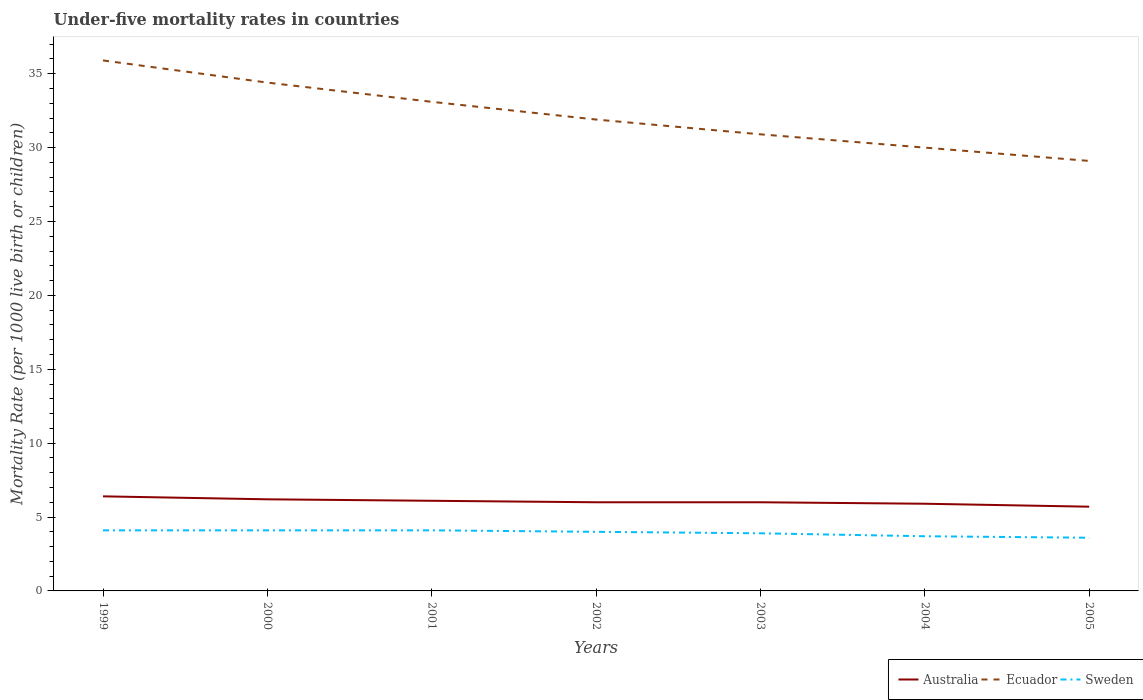How many different coloured lines are there?
Offer a very short reply. 3. Does the line corresponding to Ecuador intersect with the line corresponding to Australia?
Provide a short and direct response. No. Is the number of lines equal to the number of legend labels?
Your answer should be very brief. Yes. In which year was the under-five mortality rate in Sweden maximum?
Provide a short and direct response. 2005. What is the total under-five mortality rate in Sweden in the graph?
Provide a short and direct response. 0.1. What is the difference between the highest and the second highest under-five mortality rate in Sweden?
Offer a terse response. 0.5. Is the under-five mortality rate in Australia strictly greater than the under-five mortality rate in Sweden over the years?
Keep it short and to the point. No. What is the difference between two consecutive major ticks on the Y-axis?
Your answer should be very brief. 5. Are the values on the major ticks of Y-axis written in scientific E-notation?
Your answer should be compact. No. Does the graph contain grids?
Your answer should be compact. No. How many legend labels are there?
Make the answer very short. 3. What is the title of the graph?
Ensure brevity in your answer.  Under-five mortality rates in countries. Does "Morocco" appear as one of the legend labels in the graph?
Offer a very short reply. No. What is the label or title of the Y-axis?
Offer a very short reply. Mortality Rate (per 1000 live birth or children). What is the Mortality Rate (per 1000 live birth or children) in Ecuador in 1999?
Give a very brief answer. 35.9. What is the Mortality Rate (per 1000 live birth or children) of Ecuador in 2000?
Provide a succinct answer. 34.4. What is the Mortality Rate (per 1000 live birth or children) of Ecuador in 2001?
Your answer should be very brief. 33.1. What is the Mortality Rate (per 1000 live birth or children) in Sweden in 2001?
Your answer should be very brief. 4.1. What is the Mortality Rate (per 1000 live birth or children) in Ecuador in 2002?
Keep it short and to the point. 31.9. What is the Mortality Rate (per 1000 live birth or children) in Sweden in 2002?
Make the answer very short. 4. What is the Mortality Rate (per 1000 live birth or children) of Ecuador in 2003?
Your answer should be compact. 30.9. What is the Mortality Rate (per 1000 live birth or children) in Sweden in 2004?
Offer a very short reply. 3.7. What is the Mortality Rate (per 1000 live birth or children) of Ecuador in 2005?
Ensure brevity in your answer.  29.1. Across all years, what is the maximum Mortality Rate (per 1000 live birth or children) in Australia?
Give a very brief answer. 6.4. Across all years, what is the maximum Mortality Rate (per 1000 live birth or children) in Ecuador?
Give a very brief answer. 35.9. Across all years, what is the minimum Mortality Rate (per 1000 live birth or children) in Ecuador?
Ensure brevity in your answer.  29.1. What is the total Mortality Rate (per 1000 live birth or children) in Australia in the graph?
Provide a short and direct response. 42.3. What is the total Mortality Rate (per 1000 live birth or children) in Ecuador in the graph?
Give a very brief answer. 225.3. What is the difference between the Mortality Rate (per 1000 live birth or children) of Ecuador in 1999 and that in 2000?
Provide a succinct answer. 1.5. What is the difference between the Mortality Rate (per 1000 live birth or children) of Sweden in 1999 and that in 2000?
Make the answer very short. 0. What is the difference between the Mortality Rate (per 1000 live birth or children) in Australia in 1999 and that in 2001?
Ensure brevity in your answer.  0.3. What is the difference between the Mortality Rate (per 1000 live birth or children) of Ecuador in 1999 and that in 2001?
Offer a terse response. 2.8. What is the difference between the Mortality Rate (per 1000 live birth or children) of Australia in 1999 and that in 2002?
Your response must be concise. 0.4. What is the difference between the Mortality Rate (per 1000 live birth or children) in Sweden in 1999 and that in 2002?
Provide a short and direct response. 0.1. What is the difference between the Mortality Rate (per 1000 live birth or children) of Australia in 1999 and that in 2003?
Keep it short and to the point. 0.4. What is the difference between the Mortality Rate (per 1000 live birth or children) of Australia in 1999 and that in 2004?
Your response must be concise. 0.5. What is the difference between the Mortality Rate (per 1000 live birth or children) in Ecuador in 1999 and that in 2004?
Your answer should be very brief. 5.9. What is the difference between the Mortality Rate (per 1000 live birth or children) in Sweden in 1999 and that in 2004?
Your answer should be very brief. 0.4. What is the difference between the Mortality Rate (per 1000 live birth or children) in Ecuador in 1999 and that in 2005?
Make the answer very short. 6.8. What is the difference between the Mortality Rate (per 1000 live birth or children) of Sweden in 1999 and that in 2005?
Keep it short and to the point. 0.5. What is the difference between the Mortality Rate (per 1000 live birth or children) in Sweden in 2000 and that in 2001?
Your response must be concise. 0. What is the difference between the Mortality Rate (per 1000 live birth or children) in Australia in 2000 and that in 2003?
Offer a very short reply. 0.2. What is the difference between the Mortality Rate (per 1000 live birth or children) of Ecuador in 2000 and that in 2003?
Your response must be concise. 3.5. What is the difference between the Mortality Rate (per 1000 live birth or children) of Sweden in 2000 and that in 2003?
Provide a short and direct response. 0.2. What is the difference between the Mortality Rate (per 1000 live birth or children) of Australia in 2000 and that in 2005?
Provide a short and direct response. 0.5. What is the difference between the Mortality Rate (per 1000 live birth or children) in Ecuador in 2000 and that in 2005?
Your response must be concise. 5.3. What is the difference between the Mortality Rate (per 1000 live birth or children) of Ecuador in 2001 and that in 2002?
Provide a short and direct response. 1.2. What is the difference between the Mortality Rate (per 1000 live birth or children) in Australia in 2001 and that in 2003?
Provide a short and direct response. 0.1. What is the difference between the Mortality Rate (per 1000 live birth or children) in Ecuador in 2001 and that in 2003?
Ensure brevity in your answer.  2.2. What is the difference between the Mortality Rate (per 1000 live birth or children) of Sweden in 2001 and that in 2003?
Your answer should be compact. 0.2. What is the difference between the Mortality Rate (per 1000 live birth or children) of Australia in 2001 and that in 2004?
Your answer should be very brief. 0.2. What is the difference between the Mortality Rate (per 1000 live birth or children) of Ecuador in 2001 and that in 2004?
Ensure brevity in your answer.  3.1. What is the difference between the Mortality Rate (per 1000 live birth or children) in Australia in 2001 and that in 2005?
Your response must be concise. 0.4. What is the difference between the Mortality Rate (per 1000 live birth or children) of Sweden in 2001 and that in 2005?
Your answer should be compact. 0.5. What is the difference between the Mortality Rate (per 1000 live birth or children) in Australia in 2002 and that in 2003?
Your response must be concise. 0. What is the difference between the Mortality Rate (per 1000 live birth or children) of Sweden in 2002 and that in 2003?
Provide a short and direct response. 0.1. What is the difference between the Mortality Rate (per 1000 live birth or children) of Australia in 2002 and that in 2004?
Make the answer very short. 0.1. What is the difference between the Mortality Rate (per 1000 live birth or children) of Ecuador in 2002 and that in 2004?
Offer a very short reply. 1.9. What is the difference between the Mortality Rate (per 1000 live birth or children) in Sweden in 2002 and that in 2004?
Provide a succinct answer. 0.3. What is the difference between the Mortality Rate (per 1000 live birth or children) of Australia in 2002 and that in 2005?
Your answer should be compact. 0.3. What is the difference between the Mortality Rate (per 1000 live birth or children) of Sweden in 2002 and that in 2005?
Provide a succinct answer. 0.4. What is the difference between the Mortality Rate (per 1000 live birth or children) of Australia in 2003 and that in 2004?
Make the answer very short. 0.1. What is the difference between the Mortality Rate (per 1000 live birth or children) in Australia in 2003 and that in 2005?
Provide a succinct answer. 0.3. What is the difference between the Mortality Rate (per 1000 live birth or children) in Ecuador in 2003 and that in 2005?
Make the answer very short. 1.8. What is the difference between the Mortality Rate (per 1000 live birth or children) in Sweden in 2003 and that in 2005?
Provide a short and direct response. 0.3. What is the difference between the Mortality Rate (per 1000 live birth or children) of Australia in 2004 and that in 2005?
Your answer should be compact. 0.2. What is the difference between the Mortality Rate (per 1000 live birth or children) in Australia in 1999 and the Mortality Rate (per 1000 live birth or children) in Ecuador in 2000?
Your answer should be very brief. -28. What is the difference between the Mortality Rate (per 1000 live birth or children) in Australia in 1999 and the Mortality Rate (per 1000 live birth or children) in Sweden in 2000?
Offer a very short reply. 2.3. What is the difference between the Mortality Rate (per 1000 live birth or children) in Ecuador in 1999 and the Mortality Rate (per 1000 live birth or children) in Sweden in 2000?
Give a very brief answer. 31.8. What is the difference between the Mortality Rate (per 1000 live birth or children) in Australia in 1999 and the Mortality Rate (per 1000 live birth or children) in Ecuador in 2001?
Provide a short and direct response. -26.7. What is the difference between the Mortality Rate (per 1000 live birth or children) of Australia in 1999 and the Mortality Rate (per 1000 live birth or children) of Sweden in 2001?
Give a very brief answer. 2.3. What is the difference between the Mortality Rate (per 1000 live birth or children) of Ecuador in 1999 and the Mortality Rate (per 1000 live birth or children) of Sweden in 2001?
Keep it short and to the point. 31.8. What is the difference between the Mortality Rate (per 1000 live birth or children) of Australia in 1999 and the Mortality Rate (per 1000 live birth or children) of Ecuador in 2002?
Your answer should be compact. -25.5. What is the difference between the Mortality Rate (per 1000 live birth or children) in Ecuador in 1999 and the Mortality Rate (per 1000 live birth or children) in Sweden in 2002?
Ensure brevity in your answer.  31.9. What is the difference between the Mortality Rate (per 1000 live birth or children) in Australia in 1999 and the Mortality Rate (per 1000 live birth or children) in Ecuador in 2003?
Your answer should be very brief. -24.5. What is the difference between the Mortality Rate (per 1000 live birth or children) of Australia in 1999 and the Mortality Rate (per 1000 live birth or children) of Ecuador in 2004?
Keep it short and to the point. -23.6. What is the difference between the Mortality Rate (per 1000 live birth or children) in Ecuador in 1999 and the Mortality Rate (per 1000 live birth or children) in Sweden in 2004?
Offer a very short reply. 32.2. What is the difference between the Mortality Rate (per 1000 live birth or children) of Australia in 1999 and the Mortality Rate (per 1000 live birth or children) of Ecuador in 2005?
Make the answer very short. -22.7. What is the difference between the Mortality Rate (per 1000 live birth or children) of Ecuador in 1999 and the Mortality Rate (per 1000 live birth or children) of Sweden in 2005?
Offer a terse response. 32.3. What is the difference between the Mortality Rate (per 1000 live birth or children) in Australia in 2000 and the Mortality Rate (per 1000 live birth or children) in Ecuador in 2001?
Your response must be concise. -26.9. What is the difference between the Mortality Rate (per 1000 live birth or children) in Ecuador in 2000 and the Mortality Rate (per 1000 live birth or children) in Sweden in 2001?
Provide a short and direct response. 30.3. What is the difference between the Mortality Rate (per 1000 live birth or children) of Australia in 2000 and the Mortality Rate (per 1000 live birth or children) of Ecuador in 2002?
Provide a succinct answer. -25.7. What is the difference between the Mortality Rate (per 1000 live birth or children) in Ecuador in 2000 and the Mortality Rate (per 1000 live birth or children) in Sweden in 2002?
Provide a short and direct response. 30.4. What is the difference between the Mortality Rate (per 1000 live birth or children) of Australia in 2000 and the Mortality Rate (per 1000 live birth or children) of Ecuador in 2003?
Your response must be concise. -24.7. What is the difference between the Mortality Rate (per 1000 live birth or children) in Australia in 2000 and the Mortality Rate (per 1000 live birth or children) in Sweden in 2003?
Provide a short and direct response. 2.3. What is the difference between the Mortality Rate (per 1000 live birth or children) of Ecuador in 2000 and the Mortality Rate (per 1000 live birth or children) of Sweden in 2003?
Offer a very short reply. 30.5. What is the difference between the Mortality Rate (per 1000 live birth or children) of Australia in 2000 and the Mortality Rate (per 1000 live birth or children) of Ecuador in 2004?
Make the answer very short. -23.8. What is the difference between the Mortality Rate (per 1000 live birth or children) of Ecuador in 2000 and the Mortality Rate (per 1000 live birth or children) of Sweden in 2004?
Offer a terse response. 30.7. What is the difference between the Mortality Rate (per 1000 live birth or children) in Australia in 2000 and the Mortality Rate (per 1000 live birth or children) in Ecuador in 2005?
Your answer should be compact. -22.9. What is the difference between the Mortality Rate (per 1000 live birth or children) of Australia in 2000 and the Mortality Rate (per 1000 live birth or children) of Sweden in 2005?
Keep it short and to the point. 2.6. What is the difference between the Mortality Rate (per 1000 live birth or children) in Ecuador in 2000 and the Mortality Rate (per 1000 live birth or children) in Sweden in 2005?
Provide a short and direct response. 30.8. What is the difference between the Mortality Rate (per 1000 live birth or children) of Australia in 2001 and the Mortality Rate (per 1000 live birth or children) of Ecuador in 2002?
Your answer should be compact. -25.8. What is the difference between the Mortality Rate (per 1000 live birth or children) in Australia in 2001 and the Mortality Rate (per 1000 live birth or children) in Sweden in 2002?
Your response must be concise. 2.1. What is the difference between the Mortality Rate (per 1000 live birth or children) in Ecuador in 2001 and the Mortality Rate (per 1000 live birth or children) in Sweden in 2002?
Keep it short and to the point. 29.1. What is the difference between the Mortality Rate (per 1000 live birth or children) of Australia in 2001 and the Mortality Rate (per 1000 live birth or children) of Ecuador in 2003?
Your answer should be very brief. -24.8. What is the difference between the Mortality Rate (per 1000 live birth or children) in Ecuador in 2001 and the Mortality Rate (per 1000 live birth or children) in Sweden in 2003?
Make the answer very short. 29.2. What is the difference between the Mortality Rate (per 1000 live birth or children) of Australia in 2001 and the Mortality Rate (per 1000 live birth or children) of Ecuador in 2004?
Your response must be concise. -23.9. What is the difference between the Mortality Rate (per 1000 live birth or children) in Australia in 2001 and the Mortality Rate (per 1000 live birth or children) in Sweden in 2004?
Provide a short and direct response. 2.4. What is the difference between the Mortality Rate (per 1000 live birth or children) in Ecuador in 2001 and the Mortality Rate (per 1000 live birth or children) in Sweden in 2004?
Give a very brief answer. 29.4. What is the difference between the Mortality Rate (per 1000 live birth or children) of Australia in 2001 and the Mortality Rate (per 1000 live birth or children) of Ecuador in 2005?
Offer a terse response. -23. What is the difference between the Mortality Rate (per 1000 live birth or children) in Australia in 2001 and the Mortality Rate (per 1000 live birth or children) in Sweden in 2005?
Offer a very short reply. 2.5. What is the difference between the Mortality Rate (per 1000 live birth or children) in Ecuador in 2001 and the Mortality Rate (per 1000 live birth or children) in Sweden in 2005?
Your answer should be very brief. 29.5. What is the difference between the Mortality Rate (per 1000 live birth or children) in Australia in 2002 and the Mortality Rate (per 1000 live birth or children) in Ecuador in 2003?
Provide a succinct answer. -24.9. What is the difference between the Mortality Rate (per 1000 live birth or children) in Ecuador in 2002 and the Mortality Rate (per 1000 live birth or children) in Sweden in 2003?
Your response must be concise. 28. What is the difference between the Mortality Rate (per 1000 live birth or children) in Australia in 2002 and the Mortality Rate (per 1000 live birth or children) in Ecuador in 2004?
Provide a succinct answer. -24. What is the difference between the Mortality Rate (per 1000 live birth or children) of Ecuador in 2002 and the Mortality Rate (per 1000 live birth or children) of Sweden in 2004?
Your response must be concise. 28.2. What is the difference between the Mortality Rate (per 1000 live birth or children) in Australia in 2002 and the Mortality Rate (per 1000 live birth or children) in Ecuador in 2005?
Make the answer very short. -23.1. What is the difference between the Mortality Rate (per 1000 live birth or children) of Australia in 2002 and the Mortality Rate (per 1000 live birth or children) of Sweden in 2005?
Provide a short and direct response. 2.4. What is the difference between the Mortality Rate (per 1000 live birth or children) in Ecuador in 2002 and the Mortality Rate (per 1000 live birth or children) in Sweden in 2005?
Provide a short and direct response. 28.3. What is the difference between the Mortality Rate (per 1000 live birth or children) of Australia in 2003 and the Mortality Rate (per 1000 live birth or children) of Ecuador in 2004?
Provide a succinct answer. -24. What is the difference between the Mortality Rate (per 1000 live birth or children) of Ecuador in 2003 and the Mortality Rate (per 1000 live birth or children) of Sweden in 2004?
Give a very brief answer. 27.2. What is the difference between the Mortality Rate (per 1000 live birth or children) in Australia in 2003 and the Mortality Rate (per 1000 live birth or children) in Ecuador in 2005?
Make the answer very short. -23.1. What is the difference between the Mortality Rate (per 1000 live birth or children) in Australia in 2003 and the Mortality Rate (per 1000 live birth or children) in Sweden in 2005?
Ensure brevity in your answer.  2.4. What is the difference between the Mortality Rate (per 1000 live birth or children) of Ecuador in 2003 and the Mortality Rate (per 1000 live birth or children) of Sweden in 2005?
Offer a very short reply. 27.3. What is the difference between the Mortality Rate (per 1000 live birth or children) in Australia in 2004 and the Mortality Rate (per 1000 live birth or children) in Ecuador in 2005?
Give a very brief answer. -23.2. What is the difference between the Mortality Rate (per 1000 live birth or children) of Australia in 2004 and the Mortality Rate (per 1000 live birth or children) of Sweden in 2005?
Keep it short and to the point. 2.3. What is the difference between the Mortality Rate (per 1000 live birth or children) of Ecuador in 2004 and the Mortality Rate (per 1000 live birth or children) of Sweden in 2005?
Make the answer very short. 26.4. What is the average Mortality Rate (per 1000 live birth or children) of Australia per year?
Your response must be concise. 6.04. What is the average Mortality Rate (per 1000 live birth or children) of Ecuador per year?
Your response must be concise. 32.19. What is the average Mortality Rate (per 1000 live birth or children) in Sweden per year?
Offer a very short reply. 3.93. In the year 1999, what is the difference between the Mortality Rate (per 1000 live birth or children) in Australia and Mortality Rate (per 1000 live birth or children) in Ecuador?
Provide a short and direct response. -29.5. In the year 1999, what is the difference between the Mortality Rate (per 1000 live birth or children) of Australia and Mortality Rate (per 1000 live birth or children) of Sweden?
Offer a terse response. 2.3. In the year 1999, what is the difference between the Mortality Rate (per 1000 live birth or children) of Ecuador and Mortality Rate (per 1000 live birth or children) of Sweden?
Provide a succinct answer. 31.8. In the year 2000, what is the difference between the Mortality Rate (per 1000 live birth or children) in Australia and Mortality Rate (per 1000 live birth or children) in Ecuador?
Give a very brief answer. -28.2. In the year 2000, what is the difference between the Mortality Rate (per 1000 live birth or children) in Ecuador and Mortality Rate (per 1000 live birth or children) in Sweden?
Give a very brief answer. 30.3. In the year 2001, what is the difference between the Mortality Rate (per 1000 live birth or children) in Ecuador and Mortality Rate (per 1000 live birth or children) in Sweden?
Offer a very short reply. 29. In the year 2002, what is the difference between the Mortality Rate (per 1000 live birth or children) of Australia and Mortality Rate (per 1000 live birth or children) of Ecuador?
Ensure brevity in your answer.  -25.9. In the year 2002, what is the difference between the Mortality Rate (per 1000 live birth or children) of Ecuador and Mortality Rate (per 1000 live birth or children) of Sweden?
Provide a succinct answer. 27.9. In the year 2003, what is the difference between the Mortality Rate (per 1000 live birth or children) in Australia and Mortality Rate (per 1000 live birth or children) in Ecuador?
Provide a succinct answer. -24.9. In the year 2003, what is the difference between the Mortality Rate (per 1000 live birth or children) of Ecuador and Mortality Rate (per 1000 live birth or children) of Sweden?
Keep it short and to the point. 27. In the year 2004, what is the difference between the Mortality Rate (per 1000 live birth or children) of Australia and Mortality Rate (per 1000 live birth or children) of Ecuador?
Make the answer very short. -24.1. In the year 2004, what is the difference between the Mortality Rate (per 1000 live birth or children) in Ecuador and Mortality Rate (per 1000 live birth or children) in Sweden?
Ensure brevity in your answer.  26.3. In the year 2005, what is the difference between the Mortality Rate (per 1000 live birth or children) in Australia and Mortality Rate (per 1000 live birth or children) in Ecuador?
Ensure brevity in your answer.  -23.4. In the year 2005, what is the difference between the Mortality Rate (per 1000 live birth or children) in Australia and Mortality Rate (per 1000 live birth or children) in Sweden?
Offer a terse response. 2.1. In the year 2005, what is the difference between the Mortality Rate (per 1000 live birth or children) of Ecuador and Mortality Rate (per 1000 live birth or children) of Sweden?
Your answer should be very brief. 25.5. What is the ratio of the Mortality Rate (per 1000 live birth or children) of Australia in 1999 to that in 2000?
Provide a short and direct response. 1.03. What is the ratio of the Mortality Rate (per 1000 live birth or children) of Ecuador in 1999 to that in 2000?
Make the answer very short. 1.04. What is the ratio of the Mortality Rate (per 1000 live birth or children) in Australia in 1999 to that in 2001?
Make the answer very short. 1.05. What is the ratio of the Mortality Rate (per 1000 live birth or children) in Ecuador in 1999 to that in 2001?
Provide a succinct answer. 1.08. What is the ratio of the Mortality Rate (per 1000 live birth or children) of Sweden in 1999 to that in 2001?
Provide a short and direct response. 1. What is the ratio of the Mortality Rate (per 1000 live birth or children) in Australia in 1999 to that in 2002?
Ensure brevity in your answer.  1.07. What is the ratio of the Mortality Rate (per 1000 live birth or children) in Ecuador in 1999 to that in 2002?
Your answer should be compact. 1.13. What is the ratio of the Mortality Rate (per 1000 live birth or children) in Sweden in 1999 to that in 2002?
Give a very brief answer. 1.02. What is the ratio of the Mortality Rate (per 1000 live birth or children) of Australia in 1999 to that in 2003?
Provide a succinct answer. 1.07. What is the ratio of the Mortality Rate (per 1000 live birth or children) of Ecuador in 1999 to that in 2003?
Provide a succinct answer. 1.16. What is the ratio of the Mortality Rate (per 1000 live birth or children) in Sweden in 1999 to that in 2003?
Your answer should be compact. 1.05. What is the ratio of the Mortality Rate (per 1000 live birth or children) in Australia in 1999 to that in 2004?
Your answer should be compact. 1.08. What is the ratio of the Mortality Rate (per 1000 live birth or children) of Ecuador in 1999 to that in 2004?
Offer a terse response. 1.2. What is the ratio of the Mortality Rate (per 1000 live birth or children) of Sweden in 1999 to that in 2004?
Provide a short and direct response. 1.11. What is the ratio of the Mortality Rate (per 1000 live birth or children) of Australia in 1999 to that in 2005?
Make the answer very short. 1.12. What is the ratio of the Mortality Rate (per 1000 live birth or children) of Ecuador in 1999 to that in 2005?
Offer a terse response. 1.23. What is the ratio of the Mortality Rate (per 1000 live birth or children) of Sweden in 1999 to that in 2005?
Make the answer very short. 1.14. What is the ratio of the Mortality Rate (per 1000 live birth or children) in Australia in 2000 to that in 2001?
Give a very brief answer. 1.02. What is the ratio of the Mortality Rate (per 1000 live birth or children) in Ecuador in 2000 to that in 2001?
Provide a short and direct response. 1.04. What is the ratio of the Mortality Rate (per 1000 live birth or children) in Ecuador in 2000 to that in 2002?
Provide a short and direct response. 1.08. What is the ratio of the Mortality Rate (per 1000 live birth or children) in Sweden in 2000 to that in 2002?
Provide a short and direct response. 1.02. What is the ratio of the Mortality Rate (per 1000 live birth or children) of Australia in 2000 to that in 2003?
Ensure brevity in your answer.  1.03. What is the ratio of the Mortality Rate (per 1000 live birth or children) in Ecuador in 2000 to that in 2003?
Ensure brevity in your answer.  1.11. What is the ratio of the Mortality Rate (per 1000 live birth or children) in Sweden in 2000 to that in 2003?
Make the answer very short. 1.05. What is the ratio of the Mortality Rate (per 1000 live birth or children) of Australia in 2000 to that in 2004?
Ensure brevity in your answer.  1.05. What is the ratio of the Mortality Rate (per 1000 live birth or children) in Ecuador in 2000 to that in 2004?
Your answer should be compact. 1.15. What is the ratio of the Mortality Rate (per 1000 live birth or children) of Sweden in 2000 to that in 2004?
Give a very brief answer. 1.11. What is the ratio of the Mortality Rate (per 1000 live birth or children) of Australia in 2000 to that in 2005?
Ensure brevity in your answer.  1.09. What is the ratio of the Mortality Rate (per 1000 live birth or children) of Ecuador in 2000 to that in 2005?
Provide a short and direct response. 1.18. What is the ratio of the Mortality Rate (per 1000 live birth or children) of Sweden in 2000 to that in 2005?
Provide a short and direct response. 1.14. What is the ratio of the Mortality Rate (per 1000 live birth or children) in Australia in 2001 to that in 2002?
Make the answer very short. 1.02. What is the ratio of the Mortality Rate (per 1000 live birth or children) of Ecuador in 2001 to that in 2002?
Provide a succinct answer. 1.04. What is the ratio of the Mortality Rate (per 1000 live birth or children) of Sweden in 2001 to that in 2002?
Give a very brief answer. 1.02. What is the ratio of the Mortality Rate (per 1000 live birth or children) of Australia in 2001 to that in 2003?
Make the answer very short. 1.02. What is the ratio of the Mortality Rate (per 1000 live birth or children) in Ecuador in 2001 to that in 2003?
Your answer should be compact. 1.07. What is the ratio of the Mortality Rate (per 1000 live birth or children) in Sweden in 2001 to that in 2003?
Your answer should be compact. 1.05. What is the ratio of the Mortality Rate (per 1000 live birth or children) in Australia in 2001 to that in 2004?
Your response must be concise. 1.03. What is the ratio of the Mortality Rate (per 1000 live birth or children) of Ecuador in 2001 to that in 2004?
Your answer should be compact. 1.1. What is the ratio of the Mortality Rate (per 1000 live birth or children) in Sweden in 2001 to that in 2004?
Your answer should be compact. 1.11. What is the ratio of the Mortality Rate (per 1000 live birth or children) of Australia in 2001 to that in 2005?
Give a very brief answer. 1.07. What is the ratio of the Mortality Rate (per 1000 live birth or children) in Ecuador in 2001 to that in 2005?
Your answer should be compact. 1.14. What is the ratio of the Mortality Rate (per 1000 live birth or children) in Sweden in 2001 to that in 2005?
Keep it short and to the point. 1.14. What is the ratio of the Mortality Rate (per 1000 live birth or children) in Ecuador in 2002 to that in 2003?
Your response must be concise. 1.03. What is the ratio of the Mortality Rate (per 1000 live birth or children) of Sweden in 2002 to that in 2003?
Give a very brief answer. 1.03. What is the ratio of the Mortality Rate (per 1000 live birth or children) of Australia in 2002 to that in 2004?
Provide a short and direct response. 1.02. What is the ratio of the Mortality Rate (per 1000 live birth or children) of Ecuador in 2002 to that in 2004?
Your answer should be very brief. 1.06. What is the ratio of the Mortality Rate (per 1000 live birth or children) of Sweden in 2002 to that in 2004?
Make the answer very short. 1.08. What is the ratio of the Mortality Rate (per 1000 live birth or children) of Australia in 2002 to that in 2005?
Offer a very short reply. 1.05. What is the ratio of the Mortality Rate (per 1000 live birth or children) in Ecuador in 2002 to that in 2005?
Offer a very short reply. 1.1. What is the ratio of the Mortality Rate (per 1000 live birth or children) of Australia in 2003 to that in 2004?
Offer a very short reply. 1.02. What is the ratio of the Mortality Rate (per 1000 live birth or children) of Ecuador in 2003 to that in 2004?
Provide a short and direct response. 1.03. What is the ratio of the Mortality Rate (per 1000 live birth or children) in Sweden in 2003 to that in 2004?
Make the answer very short. 1.05. What is the ratio of the Mortality Rate (per 1000 live birth or children) in Australia in 2003 to that in 2005?
Provide a succinct answer. 1.05. What is the ratio of the Mortality Rate (per 1000 live birth or children) of Ecuador in 2003 to that in 2005?
Offer a terse response. 1.06. What is the ratio of the Mortality Rate (per 1000 live birth or children) in Australia in 2004 to that in 2005?
Offer a very short reply. 1.04. What is the ratio of the Mortality Rate (per 1000 live birth or children) of Ecuador in 2004 to that in 2005?
Make the answer very short. 1.03. What is the ratio of the Mortality Rate (per 1000 live birth or children) of Sweden in 2004 to that in 2005?
Your answer should be very brief. 1.03. What is the difference between the highest and the second highest Mortality Rate (per 1000 live birth or children) of Ecuador?
Provide a succinct answer. 1.5. What is the difference between the highest and the second highest Mortality Rate (per 1000 live birth or children) of Sweden?
Keep it short and to the point. 0. What is the difference between the highest and the lowest Mortality Rate (per 1000 live birth or children) in Sweden?
Keep it short and to the point. 0.5. 